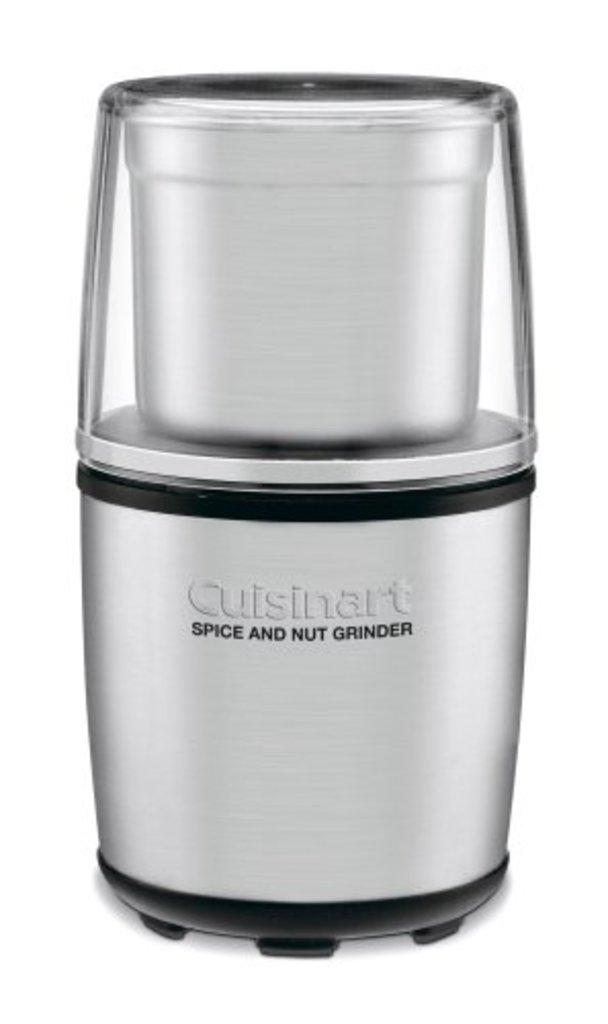<image>
Summarize the visual content of the image. A spice and nut grinder from the brand Cuisinart 